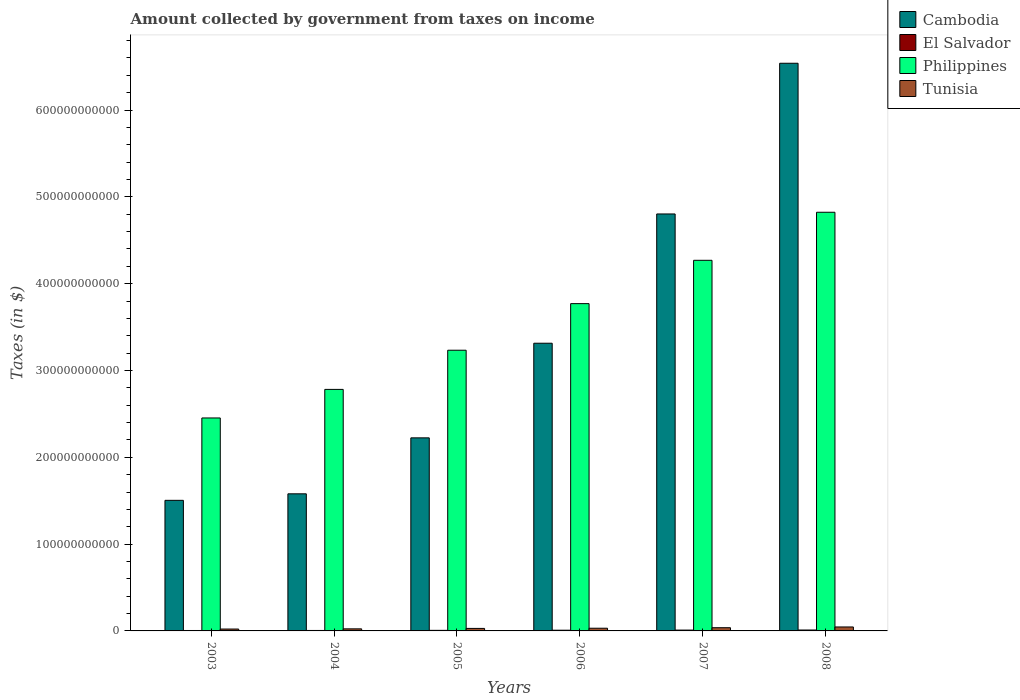How many different coloured bars are there?
Provide a short and direct response. 4. Are the number of bars on each tick of the X-axis equal?
Offer a terse response. Yes. How many bars are there on the 4th tick from the left?
Give a very brief answer. 4. What is the label of the 4th group of bars from the left?
Your answer should be very brief. 2006. What is the amount collected by government from taxes on income in El Salvador in 2006?
Ensure brevity in your answer.  8.16e+08. Across all years, what is the maximum amount collected by government from taxes on income in Tunisia?
Offer a terse response. 4.56e+09. Across all years, what is the minimum amount collected by government from taxes on income in Philippines?
Give a very brief answer. 2.45e+11. In which year was the amount collected by government from taxes on income in Tunisia minimum?
Make the answer very short. 2003. What is the total amount collected by government from taxes on income in Philippines in the graph?
Ensure brevity in your answer.  2.13e+12. What is the difference between the amount collected by government from taxes on income in Cambodia in 2003 and that in 2007?
Offer a terse response. -3.30e+11. What is the difference between the amount collected by government from taxes on income in El Salvador in 2005 and the amount collected by government from taxes on income in Cambodia in 2006?
Offer a terse response. -3.31e+11. What is the average amount collected by government from taxes on income in El Salvador per year?
Offer a terse response. 7.53e+08. In the year 2003, what is the difference between the amount collected by government from taxes on income in Cambodia and amount collected by government from taxes on income in Philippines?
Provide a short and direct response. -9.49e+1. What is the ratio of the amount collected by government from taxes on income in El Salvador in 2004 to that in 2005?
Your response must be concise. 0.79. Is the amount collected by government from taxes on income in Tunisia in 2004 less than that in 2005?
Offer a terse response. Yes. What is the difference between the highest and the second highest amount collected by government from taxes on income in Cambodia?
Provide a succinct answer. 1.74e+11. What is the difference between the highest and the lowest amount collected by government from taxes on income in El Salvador?
Keep it short and to the point. 5.52e+08. In how many years, is the amount collected by government from taxes on income in Cambodia greater than the average amount collected by government from taxes on income in Cambodia taken over all years?
Make the answer very short. 2. Is it the case that in every year, the sum of the amount collected by government from taxes on income in Tunisia and amount collected by government from taxes on income in Cambodia is greater than the sum of amount collected by government from taxes on income in El Salvador and amount collected by government from taxes on income in Philippines?
Provide a short and direct response. No. What does the 4th bar from the left in 2006 represents?
Offer a very short reply. Tunisia. What does the 1st bar from the right in 2003 represents?
Give a very brief answer. Tunisia. Are all the bars in the graph horizontal?
Offer a terse response. No. What is the difference between two consecutive major ticks on the Y-axis?
Make the answer very short. 1.00e+11. Are the values on the major ticks of Y-axis written in scientific E-notation?
Your answer should be compact. No. Does the graph contain any zero values?
Ensure brevity in your answer.  No. What is the title of the graph?
Offer a very short reply. Amount collected by government from taxes on income. Does "Mauritius" appear as one of the legend labels in the graph?
Give a very brief answer. No. What is the label or title of the X-axis?
Offer a very short reply. Years. What is the label or title of the Y-axis?
Provide a succinct answer. Taxes (in $). What is the Taxes (in $) in Cambodia in 2003?
Your answer should be compact. 1.50e+11. What is the Taxes (in $) of El Salvador in 2003?
Your answer should be very brief. 4.98e+08. What is the Taxes (in $) of Philippines in 2003?
Give a very brief answer. 2.45e+11. What is the Taxes (in $) in Tunisia in 2003?
Give a very brief answer. 2.18e+09. What is the Taxes (in $) of Cambodia in 2004?
Your answer should be very brief. 1.58e+11. What is the Taxes (in $) in El Salvador in 2004?
Offer a terse response. 5.25e+08. What is the Taxes (in $) in Philippines in 2004?
Ensure brevity in your answer.  2.78e+11. What is the Taxes (in $) in Tunisia in 2004?
Your answer should be compact. 2.39e+09. What is the Taxes (in $) in Cambodia in 2005?
Offer a very short reply. 2.22e+11. What is the Taxes (in $) of El Salvador in 2005?
Your response must be concise. 6.63e+08. What is the Taxes (in $) of Philippines in 2005?
Your response must be concise. 3.23e+11. What is the Taxes (in $) of Tunisia in 2005?
Offer a very short reply. 2.89e+09. What is the Taxes (in $) in Cambodia in 2006?
Keep it short and to the point. 3.31e+11. What is the Taxes (in $) in El Salvador in 2006?
Your answer should be compact. 8.16e+08. What is the Taxes (in $) in Philippines in 2006?
Provide a succinct answer. 3.77e+11. What is the Taxes (in $) in Tunisia in 2006?
Your answer should be very brief. 3.11e+09. What is the Taxes (in $) of Cambodia in 2007?
Your response must be concise. 4.80e+11. What is the Taxes (in $) of El Salvador in 2007?
Offer a terse response. 9.65e+08. What is the Taxes (in $) of Philippines in 2007?
Your response must be concise. 4.27e+11. What is the Taxes (in $) of Tunisia in 2007?
Offer a very short reply. 3.70e+09. What is the Taxes (in $) of Cambodia in 2008?
Offer a very short reply. 6.54e+11. What is the Taxes (in $) of El Salvador in 2008?
Keep it short and to the point. 1.05e+09. What is the Taxes (in $) in Philippines in 2008?
Your answer should be very brief. 4.82e+11. What is the Taxes (in $) in Tunisia in 2008?
Provide a succinct answer. 4.56e+09. Across all years, what is the maximum Taxes (in $) in Cambodia?
Offer a very short reply. 6.54e+11. Across all years, what is the maximum Taxes (in $) in El Salvador?
Your answer should be very brief. 1.05e+09. Across all years, what is the maximum Taxes (in $) in Philippines?
Give a very brief answer. 4.82e+11. Across all years, what is the maximum Taxes (in $) in Tunisia?
Provide a succinct answer. 4.56e+09. Across all years, what is the minimum Taxes (in $) of Cambodia?
Offer a terse response. 1.50e+11. Across all years, what is the minimum Taxes (in $) of El Salvador?
Offer a very short reply. 4.98e+08. Across all years, what is the minimum Taxes (in $) of Philippines?
Provide a short and direct response. 2.45e+11. Across all years, what is the minimum Taxes (in $) of Tunisia?
Make the answer very short. 2.18e+09. What is the total Taxes (in $) of Cambodia in the graph?
Provide a short and direct response. 2.00e+12. What is the total Taxes (in $) in El Salvador in the graph?
Ensure brevity in your answer.  4.52e+09. What is the total Taxes (in $) of Philippines in the graph?
Your answer should be very brief. 2.13e+12. What is the total Taxes (in $) in Tunisia in the graph?
Ensure brevity in your answer.  1.88e+1. What is the difference between the Taxes (in $) in Cambodia in 2003 and that in 2004?
Your response must be concise. -7.50e+09. What is the difference between the Taxes (in $) in El Salvador in 2003 and that in 2004?
Provide a short and direct response. -2.68e+07. What is the difference between the Taxes (in $) in Philippines in 2003 and that in 2004?
Ensure brevity in your answer.  -3.29e+1. What is the difference between the Taxes (in $) in Tunisia in 2003 and that in 2004?
Ensure brevity in your answer.  -2.08e+08. What is the difference between the Taxes (in $) of Cambodia in 2003 and that in 2005?
Offer a very short reply. -7.20e+1. What is the difference between the Taxes (in $) in El Salvador in 2003 and that in 2005?
Provide a short and direct response. -1.65e+08. What is the difference between the Taxes (in $) in Philippines in 2003 and that in 2005?
Give a very brief answer. -7.80e+1. What is the difference between the Taxes (in $) of Tunisia in 2003 and that in 2005?
Offer a very short reply. -7.09e+08. What is the difference between the Taxes (in $) in Cambodia in 2003 and that in 2006?
Your response must be concise. -1.81e+11. What is the difference between the Taxes (in $) of El Salvador in 2003 and that in 2006?
Keep it short and to the point. -3.18e+08. What is the difference between the Taxes (in $) of Philippines in 2003 and that in 2006?
Offer a terse response. -1.32e+11. What is the difference between the Taxes (in $) in Tunisia in 2003 and that in 2006?
Ensure brevity in your answer.  -9.30e+08. What is the difference between the Taxes (in $) in Cambodia in 2003 and that in 2007?
Offer a terse response. -3.30e+11. What is the difference between the Taxes (in $) of El Salvador in 2003 and that in 2007?
Your answer should be very brief. -4.67e+08. What is the difference between the Taxes (in $) of Philippines in 2003 and that in 2007?
Offer a very short reply. -1.82e+11. What is the difference between the Taxes (in $) of Tunisia in 2003 and that in 2007?
Make the answer very short. -1.52e+09. What is the difference between the Taxes (in $) in Cambodia in 2003 and that in 2008?
Keep it short and to the point. -5.03e+11. What is the difference between the Taxes (in $) in El Salvador in 2003 and that in 2008?
Your answer should be very brief. -5.52e+08. What is the difference between the Taxes (in $) of Philippines in 2003 and that in 2008?
Provide a short and direct response. -2.37e+11. What is the difference between the Taxes (in $) in Tunisia in 2003 and that in 2008?
Keep it short and to the point. -2.38e+09. What is the difference between the Taxes (in $) in Cambodia in 2004 and that in 2005?
Your answer should be very brief. -6.45e+1. What is the difference between the Taxes (in $) in El Salvador in 2004 and that in 2005?
Your answer should be compact. -1.38e+08. What is the difference between the Taxes (in $) in Philippines in 2004 and that in 2005?
Offer a terse response. -4.51e+1. What is the difference between the Taxes (in $) of Tunisia in 2004 and that in 2005?
Offer a terse response. -5.01e+08. What is the difference between the Taxes (in $) of Cambodia in 2004 and that in 2006?
Your response must be concise. -1.73e+11. What is the difference between the Taxes (in $) in El Salvador in 2004 and that in 2006?
Make the answer very short. -2.91e+08. What is the difference between the Taxes (in $) of Philippines in 2004 and that in 2006?
Offer a terse response. -9.88e+1. What is the difference between the Taxes (in $) of Tunisia in 2004 and that in 2006?
Provide a short and direct response. -7.22e+08. What is the difference between the Taxes (in $) in Cambodia in 2004 and that in 2007?
Ensure brevity in your answer.  -3.22e+11. What is the difference between the Taxes (in $) in El Salvador in 2004 and that in 2007?
Offer a terse response. -4.40e+08. What is the difference between the Taxes (in $) in Philippines in 2004 and that in 2007?
Your answer should be compact. -1.49e+11. What is the difference between the Taxes (in $) of Tunisia in 2004 and that in 2007?
Offer a very short reply. -1.31e+09. What is the difference between the Taxes (in $) in Cambodia in 2004 and that in 2008?
Provide a short and direct response. -4.96e+11. What is the difference between the Taxes (in $) of El Salvador in 2004 and that in 2008?
Keep it short and to the point. -5.25e+08. What is the difference between the Taxes (in $) in Philippines in 2004 and that in 2008?
Make the answer very short. -2.04e+11. What is the difference between the Taxes (in $) in Tunisia in 2004 and that in 2008?
Your response must be concise. -2.18e+09. What is the difference between the Taxes (in $) of Cambodia in 2005 and that in 2006?
Offer a terse response. -1.09e+11. What is the difference between the Taxes (in $) of El Salvador in 2005 and that in 2006?
Give a very brief answer. -1.53e+08. What is the difference between the Taxes (in $) in Philippines in 2005 and that in 2006?
Ensure brevity in your answer.  -5.37e+1. What is the difference between the Taxes (in $) of Tunisia in 2005 and that in 2006?
Your response must be concise. -2.20e+08. What is the difference between the Taxes (in $) in Cambodia in 2005 and that in 2007?
Offer a very short reply. -2.58e+11. What is the difference between the Taxes (in $) in El Salvador in 2005 and that in 2007?
Offer a terse response. -3.02e+08. What is the difference between the Taxes (in $) of Philippines in 2005 and that in 2007?
Keep it short and to the point. -1.04e+11. What is the difference between the Taxes (in $) of Tunisia in 2005 and that in 2007?
Give a very brief answer. -8.12e+08. What is the difference between the Taxes (in $) of Cambodia in 2005 and that in 2008?
Your answer should be compact. -4.31e+11. What is the difference between the Taxes (in $) of El Salvador in 2005 and that in 2008?
Offer a terse response. -3.87e+08. What is the difference between the Taxes (in $) of Philippines in 2005 and that in 2008?
Keep it short and to the point. -1.59e+11. What is the difference between the Taxes (in $) in Tunisia in 2005 and that in 2008?
Your response must be concise. -1.67e+09. What is the difference between the Taxes (in $) in Cambodia in 2006 and that in 2007?
Your answer should be very brief. -1.49e+11. What is the difference between the Taxes (in $) in El Salvador in 2006 and that in 2007?
Your response must be concise. -1.49e+08. What is the difference between the Taxes (in $) in Philippines in 2006 and that in 2007?
Provide a succinct answer. -4.99e+1. What is the difference between the Taxes (in $) of Tunisia in 2006 and that in 2007?
Provide a succinct answer. -5.91e+08. What is the difference between the Taxes (in $) of Cambodia in 2006 and that in 2008?
Your response must be concise. -3.22e+11. What is the difference between the Taxes (in $) in El Salvador in 2006 and that in 2008?
Offer a very short reply. -2.34e+08. What is the difference between the Taxes (in $) in Philippines in 2006 and that in 2008?
Keep it short and to the point. -1.05e+11. What is the difference between the Taxes (in $) in Tunisia in 2006 and that in 2008?
Keep it short and to the point. -1.45e+09. What is the difference between the Taxes (in $) of Cambodia in 2007 and that in 2008?
Provide a short and direct response. -1.74e+11. What is the difference between the Taxes (in $) in El Salvador in 2007 and that in 2008?
Give a very brief answer. -8.48e+07. What is the difference between the Taxes (in $) in Philippines in 2007 and that in 2008?
Ensure brevity in your answer.  -5.53e+1. What is the difference between the Taxes (in $) of Tunisia in 2007 and that in 2008?
Offer a very short reply. -8.63e+08. What is the difference between the Taxes (in $) in Cambodia in 2003 and the Taxes (in $) in El Salvador in 2004?
Offer a terse response. 1.50e+11. What is the difference between the Taxes (in $) in Cambodia in 2003 and the Taxes (in $) in Philippines in 2004?
Your answer should be very brief. -1.28e+11. What is the difference between the Taxes (in $) of Cambodia in 2003 and the Taxes (in $) of Tunisia in 2004?
Your response must be concise. 1.48e+11. What is the difference between the Taxes (in $) of El Salvador in 2003 and the Taxes (in $) of Philippines in 2004?
Provide a short and direct response. -2.78e+11. What is the difference between the Taxes (in $) of El Salvador in 2003 and the Taxes (in $) of Tunisia in 2004?
Ensure brevity in your answer.  -1.89e+09. What is the difference between the Taxes (in $) in Philippines in 2003 and the Taxes (in $) in Tunisia in 2004?
Offer a very short reply. 2.43e+11. What is the difference between the Taxes (in $) of Cambodia in 2003 and the Taxes (in $) of El Salvador in 2005?
Your answer should be very brief. 1.50e+11. What is the difference between the Taxes (in $) of Cambodia in 2003 and the Taxes (in $) of Philippines in 2005?
Offer a very short reply. -1.73e+11. What is the difference between the Taxes (in $) of Cambodia in 2003 and the Taxes (in $) of Tunisia in 2005?
Keep it short and to the point. 1.48e+11. What is the difference between the Taxes (in $) of El Salvador in 2003 and the Taxes (in $) of Philippines in 2005?
Keep it short and to the point. -3.23e+11. What is the difference between the Taxes (in $) of El Salvador in 2003 and the Taxes (in $) of Tunisia in 2005?
Your answer should be compact. -2.39e+09. What is the difference between the Taxes (in $) in Philippines in 2003 and the Taxes (in $) in Tunisia in 2005?
Ensure brevity in your answer.  2.42e+11. What is the difference between the Taxes (in $) of Cambodia in 2003 and the Taxes (in $) of El Salvador in 2006?
Your response must be concise. 1.50e+11. What is the difference between the Taxes (in $) of Cambodia in 2003 and the Taxes (in $) of Philippines in 2006?
Your answer should be compact. -2.27e+11. What is the difference between the Taxes (in $) of Cambodia in 2003 and the Taxes (in $) of Tunisia in 2006?
Ensure brevity in your answer.  1.47e+11. What is the difference between the Taxes (in $) in El Salvador in 2003 and the Taxes (in $) in Philippines in 2006?
Make the answer very short. -3.76e+11. What is the difference between the Taxes (in $) of El Salvador in 2003 and the Taxes (in $) of Tunisia in 2006?
Ensure brevity in your answer.  -2.61e+09. What is the difference between the Taxes (in $) of Philippines in 2003 and the Taxes (in $) of Tunisia in 2006?
Provide a succinct answer. 2.42e+11. What is the difference between the Taxes (in $) in Cambodia in 2003 and the Taxes (in $) in El Salvador in 2007?
Keep it short and to the point. 1.49e+11. What is the difference between the Taxes (in $) of Cambodia in 2003 and the Taxes (in $) of Philippines in 2007?
Keep it short and to the point. -2.76e+11. What is the difference between the Taxes (in $) of Cambodia in 2003 and the Taxes (in $) of Tunisia in 2007?
Your answer should be compact. 1.47e+11. What is the difference between the Taxes (in $) in El Salvador in 2003 and the Taxes (in $) in Philippines in 2007?
Keep it short and to the point. -4.26e+11. What is the difference between the Taxes (in $) of El Salvador in 2003 and the Taxes (in $) of Tunisia in 2007?
Provide a succinct answer. -3.20e+09. What is the difference between the Taxes (in $) of Philippines in 2003 and the Taxes (in $) of Tunisia in 2007?
Ensure brevity in your answer.  2.42e+11. What is the difference between the Taxes (in $) in Cambodia in 2003 and the Taxes (in $) in El Salvador in 2008?
Make the answer very short. 1.49e+11. What is the difference between the Taxes (in $) of Cambodia in 2003 and the Taxes (in $) of Philippines in 2008?
Offer a very short reply. -3.32e+11. What is the difference between the Taxes (in $) in Cambodia in 2003 and the Taxes (in $) in Tunisia in 2008?
Your answer should be compact. 1.46e+11. What is the difference between the Taxes (in $) in El Salvador in 2003 and the Taxes (in $) in Philippines in 2008?
Offer a terse response. -4.82e+11. What is the difference between the Taxes (in $) of El Salvador in 2003 and the Taxes (in $) of Tunisia in 2008?
Provide a short and direct response. -4.06e+09. What is the difference between the Taxes (in $) in Philippines in 2003 and the Taxes (in $) in Tunisia in 2008?
Your response must be concise. 2.41e+11. What is the difference between the Taxes (in $) of Cambodia in 2004 and the Taxes (in $) of El Salvador in 2005?
Offer a very short reply. 1.57e+11. What is the difference between the Taxes (in $) in Cambodia in 2004 and the Taxes (in $) in Philippines in 2005?
Your answer should be compact. -1.65e+11. What is the difference between the Taxes (in $) of Cambodia in 2004 and the Taxes (in $) of Tunisia in 2005?
Give a very brief answer. 1.55e+11. What is the difference between the Taxes (in $) in El Salvador in 2004 and the Taxes (in $) in Philippines in 2005?
Make the answer very short. -3.23e+11. What is the difference between the Taxes (in $) of El Salvador in 2004 and the Taxes (in $) of Tunisia in 2005?
Your answer should be very brief. -2.36e+09. What is the difference between the Taxes (in $) in Philippines in 2004 and the Taxes (in $) in Tunisia in 2005?
Your answer should be compact. 2.75e+11. What is the difference between the Taxes (in $) of Cambodia in 2004 and the Taxes (in $) of El Salvador in 2006?
Offer a very short reply. 1.57e+11. What is the difference between the Taxes (in $) in Cambodia in 2004 and the Taxes (in $) in Philippines in 2006?
Your answer should be compact. -2.19e+11. What is the difference between the Taxes (in $) of Cambodia in 2004 and the Taxes (in $) of Tunisia in 2006?
Provide a succinct answer. 1.55e+11. What is the difference between the Taxes (in $) in El Salvador in 2004 and the Taxes (in $) in Philippines in 2006?
Your answer should be compact. -3.76e+11. What is the difference between the Taxes (in $) in El Salvador in 2004 and the Taxes (in $) in Tunisia in 2006?
Offer a terse response. -2.58e+09. What is the difference between the Taxes (in $) in Philippines in 2004 and the Taxes (in $) in Tunisia in 2006?
Give a very brief answer. 2.75e+11. What is the difference between the Taxes (in $) in Cambodia in 2004 and the Taxes (in $) in El Salvador in 2007?
Give a very brief answer. 1.57e+11. What is the difference between the Taxes (in $) in Cambodia in 2004 and the Taxes (in $) in Philippines in 2007?
Your response must be concise. -2.69e+11. What is the difference between the Taxes (in $) in Cambodia in 2004 and the Taxes (in $) in Tunisia in 2007?
Ensure brevity in your answer.  1.54e+11. What is the difference between the Taxes (in $) in El Salvador in 2004 and the Taxes (in $) in Philippines in 2007?
Ensure brevity in your answer.  -4.26e+11. What is the difference between the Taxes (in $) in El Salvador in 2004 and the Taxes (in $) in Tunisia in 2007?
Offer a very short reply. -3.17e+09. What is the difference between the Taxes (in $) of Philippines in 2004 and the Taxes (in $) of Tunisia in 2007?
Offer a terse response. 2.75e+11. What is the difference between the Taxes (in $) of Cambodia in 2004 and the Taxes (in $) of El Salvador in 2008?
Your answer should be very brief. 1.57e+11. What is the difference between the Taxes (in $) of Cambodia in 2004 and the Taxes (in $) of Philippines in 2008?
Your answer should be compact. -3.24e+11. What is the difference between the Taxes (in $) of Cambodia in 2004 and the Taxes (in $) of Tunisia in 2008?
Give a very brief answer. 1.53e+11. What is the difference between the Taxes (in $) in El Salvador in 2004 and the Taxes (in $) in Philippines in 2008?
Make the answer very short. -4.82e+11. What is the difference between the Taxes (in $) of El Salvador in 2004 and the Taxes (in $) of Tunisia in 2008?
Your answer should be very brief. -4.04e+09. What is the difference between the Taxes (in $) in Philippines in 2004 and the Taxes (in $) in Tunisia in 2008?
Provide a short and direct response. 2.74e+11. What is the difference between the Taxes (in $) of Cambodia in 2005 and the Taxes (in $) of El Salvador in 2006?
Provide a succinct answer. 2.22e+11. What is the difference between the Taxes (in $) in Cambodia in 2005 and the Taxes (in $) in Philippines in 2006?
Make the answer very short. -1.55e+11. What is the difference between the Taxes (in $) in Cambodia in 2005 and the Taxes (in $) in Tunisia in 2006?
Give a very brief answer. 2.19e+11. What is the difference between the Taxes (in $) in El Salvador in 2005 and the Taxes (in $) in Philippines in 2006?
Ensure brevity in your answer.  -3.76e+11. What is the difference between the Taxes (in $) in El Salvador in 2005 and the Taxes (in $) in Tunisia in 2006?
Give a very brief answer. -2.44e+09. What is the difference between the Taxes (in $) in Philippines in 2005 and the Taxes (in $) in Tunisia in 2006?
Your response must be concise. 3.20e+11. What is the difference between the Taxes (in $) in Cambodia in 2005 and the Taxes (in $) in El Salvador in 2007?
Offer a terse response. 2.21e+11. What is the difference between the Taxes (in $) in Cambodia in 2005 and the Taxes (in $) in Philippines in 2007?
Your answer should be compact. -2.05e+11. What is the difference between the Taxes (in $) of Cambodia in 2005 and the Taxes (in $) of Tunisia in 2007?
Provide a succinct answer. 2.19e+11. What is the difference between the Taxes (in $) of El Salvador in 2005 and the Taxes (in $) of Philippines in 2007?
Your answer should be compact. -4.26e+11. What is the difference between the Taxes (in $) in El Salvador in 2005 and the Taxes (in $) in Tunisia in 2007?
Your answer should be very brief. -3.04e+09. What is the difference between the Taxes (in $) of Philippines in 2005 and the Taxes (in $) of Tunisia in 2007?
Make the answer very short. 3.20e+11. What is the difference between the Taxes (in $) of Cambodia in 2005 and the Taxes (in $) of El Salvador in 2008?
Make the answer very short. 2.21e+11. What is the difference between the Taxes (in $) of Cambodia in 2005 and the Taxes (in $) of Philippines in 2008?
Make the answer very short. -2.60e+11. What is the difference between the Taxes (in $) in Cambodia in 2005 and the Taxes (in $) in Tunisia in 2008?
Offer a very short reply. 2.18e+11. What is the difference between the Taxes (in $) in El Salvador in 2005 and the Taxes (in $) in Philippines in 2008?
Make the answer very short. -4.82e+11. What is the difference between the Taxes (in $) of El Salvador in 2005 and the Taxes (in $) of Tunisia in 2008?
Provide a succinct answer. -3.90e+09. What is the difference between the Taxes (in $) in Philippines in 2005 and the Taxes (in $) in Tunisia in 2008?
Offer a very short reply. 3.19e+11. What is the difference between the Taxes (in $) of Cambodia in 2006 and the Taxes (in $) of El Salvador in 2007?
Offer a very short reply. 3.30e+11. What is the difference between the Taxes (in $) in Cambodia in 2006 and the Taxes (in $) in Philippines in 2007?
Provide a succinct answer. -9.55e+1. What is the difference between the Taxes (in $) of Cambodia in 2006 and the Taxes (in $) of Tunisia in 2007?
Give a very brief answer. 3.28e+11. What is the difference between the Taxes (in $) in El Salvador in 2006 and the Taxes (in $) in Philippines in 2007?
Your answer should be very brief. -4.26e+11. What is the difference between the Taxes (in $) in El Salvador in 2006 and the Taxes (in $) in Tunisia in 2007?
Offer a very short reply. -2.88e+09. What is the difference between the Taxes (in $) in Philippines in 2006 and the Taxes (in $) in Tunisia in 2007?
Keep it short and to the point. 3.73e+11. What is the difference between the Taxes (in $) of Cambodia in 2006 and the Taxes (in $) of El Salvador in 2008?
Offer a very short reply. 3.30e+11. What is the difference between the Taxes (in $) of Cambodia in 2006 and the Taxes (in $) of Philippines in 2008?
Ensure brevity in your answer.  -1.51e+11. What is the difference between the Taxes (in $) in Cambodia in 2006 and the Taxes (in $) in Tunisia in 2008?
Your answer should be compact. 3.27e+11. What is the difference between the Taxes (in $) of El Salvador in 2006 and the Taxes (in $) of Philippines in 2008?
Give a very brief answer. -4.81e+11. What is the difference between the Taxes (in $) in El Salvador in 2006 and the Taxes (in $) in Tunisia in 2008?
Your answer should be compact. -3.74e+09. What is the difference between the Taxes (in $) of Philippines in 2006 and the Taxes (in $) of Tunisia in 2008?
Offer a very short reply. 3.72e+11. What is the difference between the Taxes (in $) of Cambodia in 2007 and the Taxes (in $) of El Salvador in 2008?
Give a very brief answer. 4.79e+11. What is the difference between the Taxes (in $) in Cambodia in 2007 and the Taxes (in $) in Philippines in 2008?
Provide a succinct answer. -1.96e+09. What is the difference between the Taxes (in $) of Cambodia in 2007 and the Taxes (in $) of Tunisia in 2008?
Ensure brevity in your answer.  4.76e+11. What is the difference between the Taxes (in $) in El Salvador in 2007 and the Taxes (in $) in Philippines in 2008?
Provide a succinct answer. -4.81e+11. What is the difference between the Taxes (in $) in El Salvador in 2007 and the Taxes (in $) in Tunisia in 2008?
Give a very brief answer. -3.60e+09. What is the difference between the Taxes (in $) in Philippines in 2007 and the Taxes (in $) in Tunisia in 2008?
Ensure brevity in your answer.  4.22e+11. What is the average Taxes (in $) in Cambodia per year?
Your answer should be compact. 3.33e+11. What is the average Taxes (in $) of El Salvador per year?
Ensure brevity in your answer.  7.53e+08. What is the average Taxes (in $) of Philippines per year?
Offer a very short reply. 3.55e+11. What is the average Taxes (in $) in Tunisia per year?
Make the answer very short. 3.14e+09. In the year 2003, what is the difference between the Taxes (in $) of Cambodia and Taxes (in $) of El Salvador?
Give a very brief answer. 1.50e+11. In the year 2003, what is the difference between the Taxes (in $) in Cambodia and Taxes (in $) in Philippines?
Your response must be concise. -9.49e+1. In the year 2003, what is the difference between the Taxes (in $) in Cambodia and Taxes (in $) in Tunisia?
Your answer should be compact. 1.48e+11. In the year 2003, what is the difference between the Taxes (in $) in El Salvador and Taxes (in $) in Philippines?
Ensure brevity in your answer.  -2.45e+11. In the year 2003, what is the difference between the Taxes (in $) in El Salvador and Taxes (in $) in Tunisia?
Offer a terse response. -1.68e+09. In the year 2003, what is the difference between the Taxes (in $) in Philippines and Taxes (in $) in Tunisia?
Your answer should be compact. 2.43e+11. In the year 2004, what is the difference between the Taxes (in $) of Cambodia and Taxes (in $) of El Salvador?
Provide a short and direct response. 1.57e+11. In the year 2004, what is the difference between the Taxes (in $) in Cambodia and Taxes (in $) in Philippines?
Offer a terse response. -1.20e+11. In the year 2004, what is the difference between the Taxes (in $) in Cambodia and Taxes (in $) in Tunisia?
Provide a short and direct response. 1.56e+11. In the year 2004, what is the difference between the Taxes (in $) in El Salvador and Taxes (in $) in Philippines?
Offer a very short reply. -2.78e+11. In the year 2004, what is the difference between the Taxes (in $) of El Salvador and Taxes (in $) of Tunisia?
Keep it short and to the point. -1.86e+09. In the year 2004, what is the difference between the Taxes (in $) in Philippines and Taxes (in $) in Tunisia?
Your answer should be compact. 2.76e+11. In the year 2005, what is the difference between the Taxes (in $) in Cambodia and Taxes (in $) in El Salvador?
Provide a short and direct response. 2.22e+11. In the year 2005, what is the difference between the Taxes (in $) of Cambodia and Taxes (in $) of Philippines?
Offer a very short reply. -1.01e+11. In the year 2005, what is the difference between the Taxes (in $) of Cambodia and Taxes (in $) of Tunisia?
Keep it short and to the point. 2.19e+11. In the year 2005, what is the difference between the Taxes (in $) in El Salvador and Taxes (in $) in Philippines?
Your response must be concise. -3.23e+11. In the year 2005, what is the difference between the Taxes (in $) of El Salvador and Taxes (in $) of Tunisia?
Your answer should be very brief. -2.22e+09. In the year 2005, what is the difference between the Taxes (in $) of Philippines and Taxes (in $) of Tunisia?
Ensure brevity in your answer.  3.20e+11. In the year 2006, what is the difference between the Taxes (in $) in Cambodia and Taxes (in $) in El Salvador?
Give a very brief answer. 3.31e+11. In the year 2006, what is the difference between the Taxes (in $) in Cambodia and Taxes (in $) in Philippines?
Keep it short and to the point. -4.56e+1. In the year 2006, what is the difference between the Taxes (in $) of Cambodia and Taxes (in $) of Tunisia?
Provide a short and direct response. 3.28e+11. In the year 2006, what is the difference between the Taxes (in $) in El Salvador and Taxes (in $) in Philippines?
Offer a very short reply. -3.76e+11. In the year 2006, what is the difference between the Taxes (in $) in El Salvador and Taxes (in $) in Tunisia?
Keep it short and to the point. -2.29e+09. In the year 2006, what is the difference between the Taxes (in $) in Philippines and Taxes (in $) in Tunisia?
Make the answer very short. 3.74e+11. In the year 2007, what is the difference between the Taxes (in $) in Cambodia and Taxes (in $) in El Salvador?
Offer a very short reply. 4.79e+11. In the year 2007, what is the difference between the Taxes (in $) of Cambodia and Taxes (in $) of Philippines?
Make the answer very short. 5.34e+1. In the year 2007, what is the difference between the Taxes (in $) in Cambodia and Taxes (in $) in Tunisia?
Ensure brevity in your answer.  4.77e+11. In the year 2007, what is the difference between the Taxes (in $) in El Salvador and Taxes (in $) in Philippines?
Your answer should be compact. -4.26e+11. In the year 2007, what is the difference between the Taxes (in $) in El Salvador and Taxes (in $) in Tunisia?
Ensure brevity in your answer.  -2.73e+09. In the year 2007, what is the difference between the Taxes (in $) of Philippines and Taxes (in $) of Tunisia?
Provide a succinct answer. 4.23e+11. In the year 2008, what is the difference between the Taxes (in $) in Cambodia and Taxes (in $) in El Salvador?
Ensure brevity in your answer.  6.53e+11. In the year 2008, what is the difference between the Taxes (in $) of Cambodia and Taxes (in $) of Philippines?
Offer a terse response. 1.72e+11. In the year 2008, what is the difference between the Taxes (in $) of Cambodia and Taxes (in $) of Tunisia?
Provide a succinct answer. 6.49e+11. In the year 2008, what is the difference between the Taxes (in $) of El Salvador and Taxes (in $) of Philippines?
Provide a succinct answer. -4.81e+11. In the year 2008, what is the difference between the Taxes (in $) of El Salvador and Taxes (in $) of Tunisia?
Provide a short and direct response. -3.51e+09. In the year 2008, what is the difference between the Taxes (in $) in Philippines and Taxes (in $) in Tunisia?
Your answer should be compact. 4.78e+11. What is the ratio of the Taxes (in $) of Cambodia in 2003 to that in 2004?
Provide a succinct answer. 0.95. What is the ratio of the Taxes (in $) of El Salvador in 2003 to that in 2004?
Offer a terse response. 0.95. What is the ratio of the Taxes (in $) in Philippines in 2003 to that in 2004?
Your answer should be very brief. 0.88. What is the ratio of the Taxes (in $) of Tunisia in 2003 to that in 2004?
Keep it short and to the point. 0.91. What is the ratio of the Taxes (in $) in Cambodia in 2003 to that in 2005?
Provide a succinct answer. 0.68. What is the ratio of the Taxes (in $) in El Salvador in 2003 to that in 2005?
Offer a very short reply. 0.75. What is the ratio of the Taxes (in $) of Philippines in 2003 to that in 2005?
Keep it short and to the point. 0.76. What is the ratio of the Taxes (in $) in Tunisia in 2003 to that in 2005?
Keep it short and to the point. 0.75. What is the ratio of the Taxes (in $) in Cambodia in 2003 to that in 2006?
Make the answer very short. 0.45. What is the ratio of the Taxes (in $) in El Salvador in 2003 to that in 2006?
Keep it short and to the point. 0.61. What is the ratio of the Taxes (in $) of Philippines in 2003 to that in 2006?
Your answer should be very brief. 0.65. What is the ratio of the Taxes (in $) of Tunisia in 2003 to that in 2006?
Give a very brief answer. 0.7. What is the ratio of the Taxes (in $) in Cambodia in 2003 to that in 2007?
Make the answer very short. 0.31. What is the ratio of the Taxes (in $) of El Salvador in 2003 to that in 2007?
Your response must be concise. 0.52. What is the ratio of the Taxes (in $) of Philippines in 2003 to that in 2007?
Provide a succinct answer. 0.57. What is the ratio of the Taxes (in $) in Tunisia in 2003 to that in 2007?
Keep it short and to the point. 0.59. What is the ratio of the Taxes (in $) in Cambodia in 2003 to that in 2008?
Offer a very short reply. 0.23. What is the ratio of the Taxes (in $) in El Salvador in 2003 to that in 2008?
Your answer should be compact. 0.47. What is the ratio of the Taxes (in $) in Philippines in 2003 to that in 2008?
Keep it short and to the point. 0.51. What is the ratio of the Taxes (in $) of Tunisia in 2003 to that in 2008?
Keep it short and to the point. 0.48. What is the ratio of the Taxes (in $) in Cambodia in 2004 to that in 2005?
Offer a terse response. 0.71. What is the ratio of the Taxes (in $) in El Salvador in 2004 to that in 2005?
Keep it short and to the point. 0.79. What is the ratio of the Taxes (in $) of Philippines in 2004 to that in 2005?
Offer a very short reply. 0.86. What is the ratio of the Taxes (in $) of Tunisia in 2004 to that in 2005?
Your response must be concise. 0.83. What is the ratio of the Taxes (in $) in Cambodia in 2004 to that in 2006?
Give a very brief answer. 0.48. What is the ratio of the Taxes (in $) of El Salvador in 2004 to that in 2006?
Provide a short and direct response. 0.64. What is the ratio of the Taxes (in $) of Philippines in 2004 to that in 2006?
Give a very brief answer. 0.74. What is the ratio of the Taxes (in $) in Tunisia in 2004 to that in 2006?
Give a very brief answer. 0.77. What is the ratio of the Taxes (in $) of Cambodia in 2004 to that in 2007?
Your response must be concise. 0.33. What is the ratio of the Taxes (in $) of El Salvador in 2004 to that in 2007?
Provide a succinct answer. 0.54. What is the ratio of the Taxes (in $) in Philippines in 2004 to that in 2007?
Offer a very short reply. 0.65. What is the ratio of the Taxes (in $) in Tunisia in 2004 to that in 2007?
Keep it short and to the point. 0.65. What is the ratio of the Taxes (in $) in Cambodia in 2004 to that in 2008?
Keep it short and to the point. 0.24. What is the ratio of the Taxes (in $) of El Salvador in 2004 to that in 2008?
Keep it short and to the point. 0.5. What is the ratio of the Taxes (in $) in Philippines in 2004 to that in 2008?
Give a very brief answer. 0.58. What is the ratio of the Taxes (in $) of Tunisia in 2004 to that in 2008?
Offer a very short reply. 0.52. What is the ratio of the Taxes (in $) in Cambodia in 2005 to that in 2006?
Provide a short and direct response. 0.67. What is the ratio of the Taxes (in $) of El Salvador in 2005 to that in 2006?
Offer a terse response. 0.81. What is the ratio of the Taxes (in $) of Philippines in 2005 to that in 2006?
Your answer should be compact. 0.86. What is the ratio of the Taxes (in $) of Tunisia in 2005 to that in 2006?
Offer a terse response. 0.93. What is the ratio of the Taxes (in $) in Cambodia in 2005 to that in 2007?
Your answer should be compact. 0.46. What is the ratio of the Taxes (in $) in El Salvador in 2005 to that in 2007?
Offer a very short reply. 0.69. What is the ratio of the Taxes (in $) in Philippines in 2005 to that in 2007?
Your answer should be very brief. 0.76. What is the ratio of the Taxes (in $) of Tunisia in 2005 to that in 2007?
Offer a very short reply. 0.78. What is the ratio of the Taxes (in $) of Cambodia in 2005 to that in 2008?
Your answer should be very brief. 0.34. What is the ratio of the Taxes (in $) of El Salvador in 2005 to that in 2008?
Give a very brief answer. 0.63. What is the ratio of the Taxes (in $) of Philippines in 2005 to that in 2008?
Offer a very short reply. 0.67. What is the ratio of the Taxes (in $) in Tunisia in 2005 to that in 2008?
Offer a very short reply. 0.63. What is the ratio of the Taxes (in $) of Cambodia in 2006 to that in 2007?
Offer a terse response. 0.69. What is the ratio of the Taxes (in $) of El Salvador in 2006 to that in 2007?
Keep it short and to the point. 0.85. What is the ratio of the Taxes (in $) in Philippines in 2006 to that in 2007?
Give a very brief answer. 0.88. What is the ratio of the Taxes (in $) in Tunisia in 2006 to that in 2007?
Give a very brief answer. 0.84. What is the ratio of the Taxes (in $) in Cambodia in 2006 to that in 2008?
Give a very brief answer. 0.51. What is the ratio of the Taxes (in $) in El Salvador in 2006 to that in 2008?
Your response must be concise. 0.78. What is the ratio of the Taxes (in $) of Philippines in 2006 to that in 2008?
Your answer should be very brief. 0.78. What is the ratio of the Taxes (in $) of Tunisia in 2006 to that in 2008?
Your response must be concise. 0.68. What is the ratio of the Taxes (in $) in Cambodia in 2007 to that in 2008?
Provide a succinct answer. 0.73. What is the ratio of the Taxes (in $) in El Salvador in 2007 to that in 2008?
Make the answer very short. 0.92. What is the ratio of the Taxes (in $) in Philippines in 2007 to that in 2008?
Offer a terse response. 0.89. What is the ratio of the Taxes (in $) of Tunisia in 2007 to that in 2008?
Provide a succinct answer. 0.81. What is the difference between the highest and the second highest Taxes (in $) in Cambodia?
Make the answer very short. 1.74e+11. What is the difference between the highest and the second highest Taxes (in $) in El Salvador?
Offer a very short reply. 8.48e+07. What is the difference between the highest and the second highest Taxes (in $) of Philippines?
Make the answer very short. 5.53e+1. What is the difference between the highest and the second highest Taxes (in $) of Tunisia?
Provide a succinct answer. 8.63e+08. What is the difference between the highest and the lowest Taxes (in $) in Cambodia?
Provide a succinct answer. 5.03e+11. What is the difference between the highest and the lowest Taxes (in $) in El Salvador?
Make the answer very short. 5.52e+08. What is the difference between the highest and the lowest Taxes (in $) of Philippines?
Provide a succinct answer. 2.37e+11. What is the difference between the highest and the lowest Taxes (in $) of Tunisia?
Offer a very short reply. 2.38e+09. 